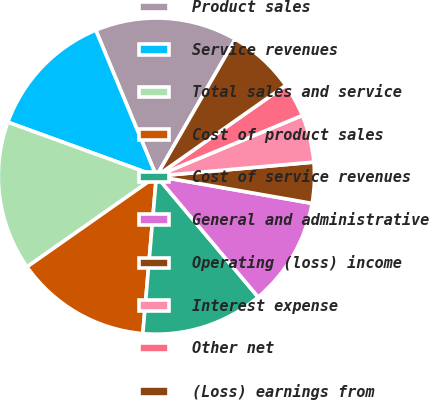<chart> <loc_0><loc_0><loc_500><loc_500><pie_chart><fcel>Product sales<fcel>Service revenues<fcel>Total sales and service<fcel>Cost of product sales<fcel>Cost of service revenues<fcel>General and administrative<fcel>Operating (loss) income<fcel>Interest expense<fcel>Other net<fcel>(Loss) earnings from<nl><fcel>14.58%<fcel>13.19%<fcel>15.28%<fcel>13.89%<fcel>12.5%<fcel>11.11%<fcel>4.17%<fcel>4.86%<fcel>3.47%<fcel>6.94%<nl></chart> 